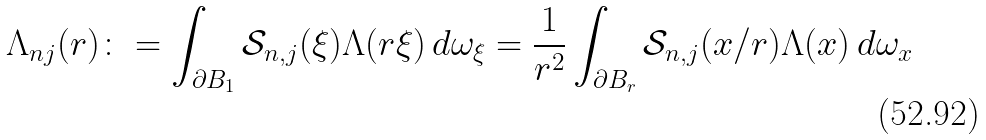Convert formula to latex. <formula><loc_0><loc_0><loc_500><loc_500>\Lambda _ { n j } ( r ) \colon = \int _ { \partial B _ { 1 } } \mathcal { S } _ { n , j } ( \xi ) \Lambda ( r \xi ) \, d \omega _ { \xi } = \frac { 1 } { r ^ { 2 } } \int _ { \partial B _ { r } } \mathcal { S } _ { n , j } ( x / r ) \Lambda ( x ) \, d \omega _ { x }</formula> 